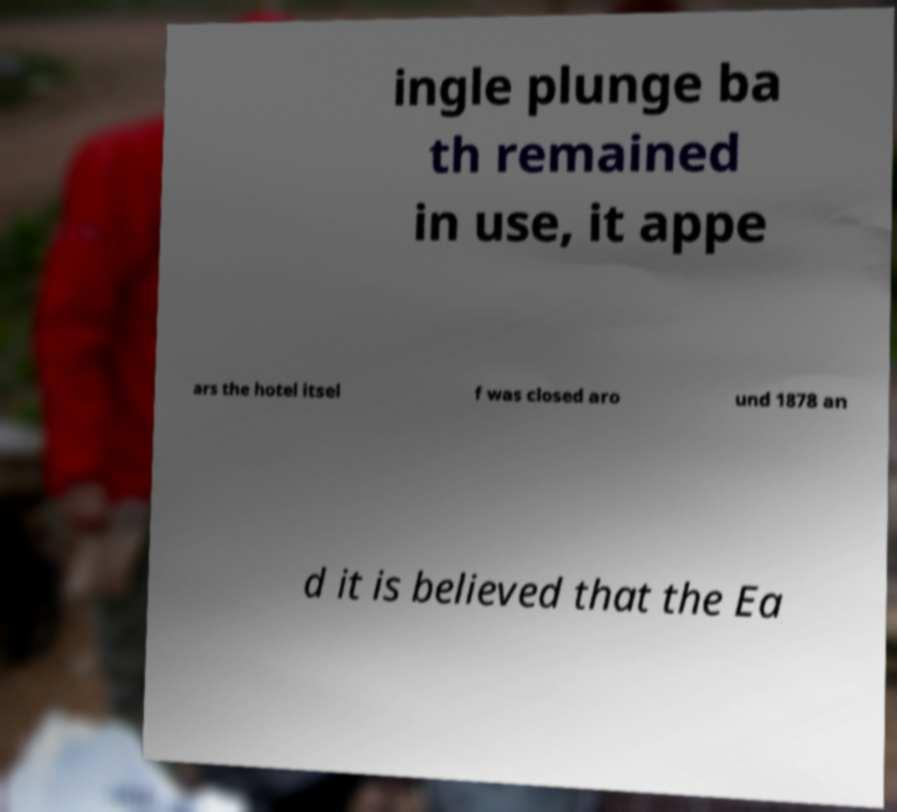I need the written content from this picture converted into text. Can you do that? ingle plunge ba th remained in use, it appe ars the hotel itsel f was closed aro und 1878 an d it is believed that the Ea 